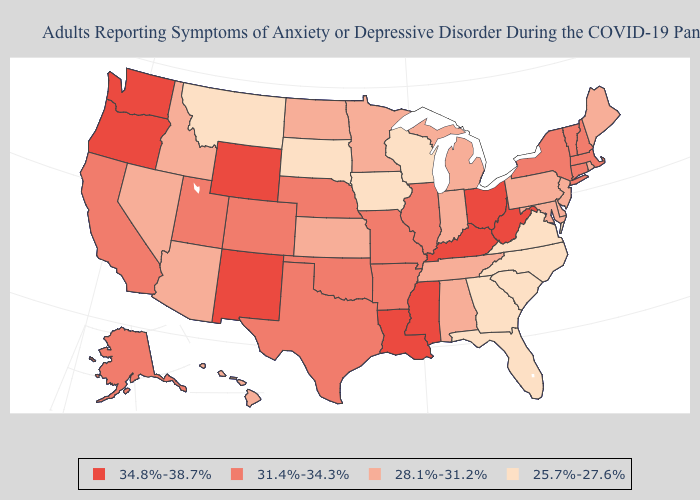What is the lowest value in the West?
Short answer required. 25.7%-27.6%. Among the states that border New York , does Connecticut have the lowest value?
Concise answer only. No. Name the states that have a value in the range 31.4%-34.3%?
Give a very brief answer. Alaska, Arkansas, California, Colorado, Connecticut, Illinois, Massachusetts, Missouri, Nebraska, New Hampshire, New York, Oklahoma, Texas, Utah, Vermont. Among the states that border South Dakota , which have the highest value?
Short answer required. Wyoming. What is the value of West Virginia?
Answer briefly. 34.8%-38.7%. Is the legend a continuous bar?
Short answer required. No. What is the lowest value in the South?
Be succinct. 25.7%-27.6%. Does Maryland have a lower value than Maine?
Short answer required. No. Does Connecticut have a higher value than Delaware?
Give a very brief answer. Yes. Does New Hampshire have the highest value in the Northeast?
Be succinct. Yes. What is the value of New Mexico?
Short answer required. 34.8%-38.7%. Does Vermont have a higher value than Florida?
Be succinct. Yes. What is the highest value in states that border South Dakota?
Write a very short answer. 34.8%-38.7%. Name the states that have a value in the range 34.8%-38.7%?
Write a very short answer. Kentucky, Louisiana, Mississippi, New Mexico, Ohio, Oregon, Washington, West Virginia, Wyoming. Among the states that border Iowa , which have the lowest value?
Quick response, please. South Dakota, Wisconsin. 